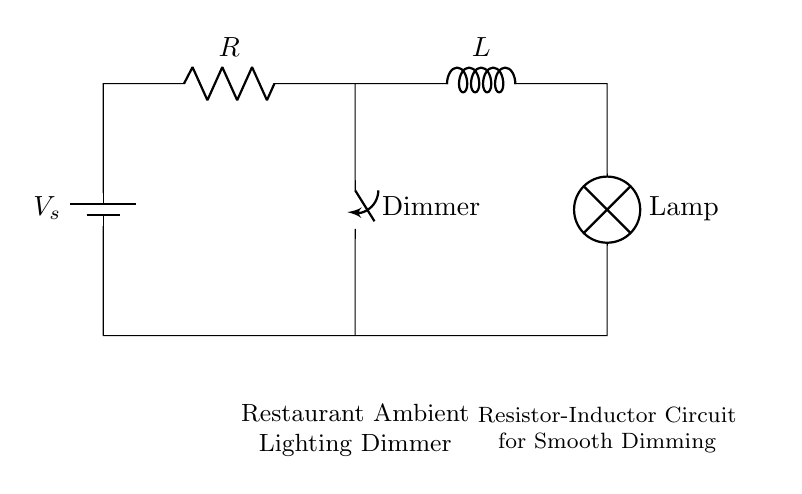What is the component labeled as R? The component labeled as R is a resistor, which is used to limit the current flowing through the circuit.
Answer: Resistor What type of circuit is this? This is a resistor-inductor circuit, as indicated by the presence of both a resistor and an inductor, used for creating a dimming effect.
Answer: Resistor-Inductor What is the purpose of the dimmer switch? The dimmer switch controls the resistance in the circuit, allowing the user to adjust the brightness of the lamp by varying the current flowing through it.
Answer: Brightness control Which component stores energy in the circuit? The inductor, represented by L, stores energy in its magnetic field when current flows through it, contributing to the smooth dimming effect.
Answer: Inductor What is the voltage source in this circuit? The component marked as V_s is the voltage source, supplying the electrical energy needed to power the circuit and the lamp.
Answer: Voltage source How does the inductor affect the dimming of the lamp? The inductor smooths out the current flow, preventing sudden changes that can result in flickering, enabling a gradual dimming effect.
Answer: Smooth dimming What is the overall purpose of this circuit in a restaurant? The overall purpose is to provide adjustable ambient lighting, enhancing the atmosphere of the restaurant while catering to customers’ preferences.
Answer: Ambient lighting 